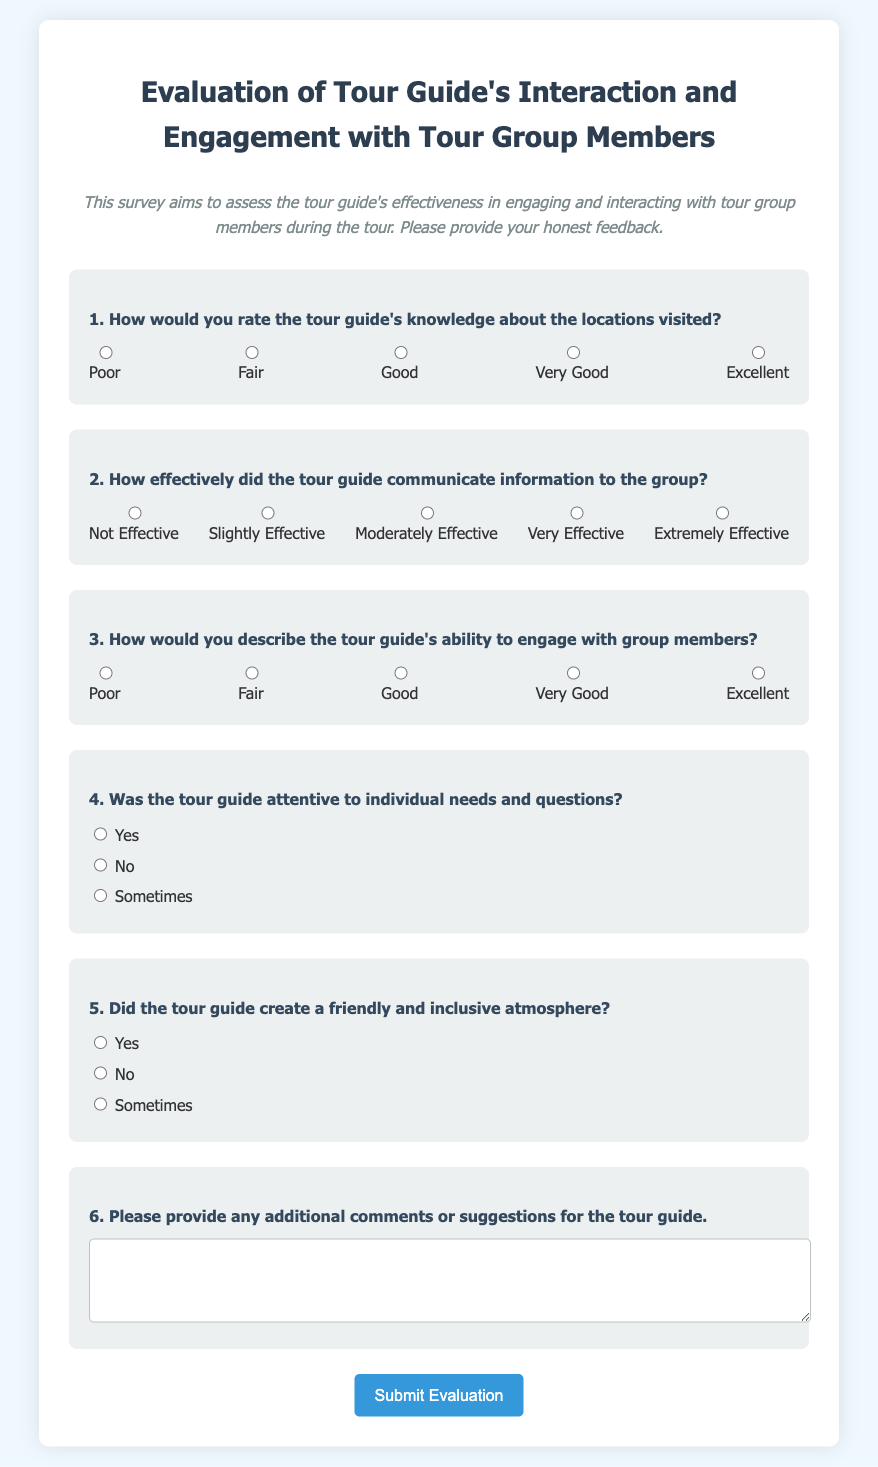What is the title of the survey? The title of the survey is stated at the top of the document, which assesses the effectiveness of the tour guide's engaging methods.
Answer: Evaluation of Tour Guide's Interaction and Engagement with Tour Group Members How many rating options are provided for the first question? The first question contains five rating options, which range from Poor to Excellent.
Answer: Five What type of question is question four? The fourth question is a multiple-choice question that requires a yes, no, or sometimes response regarding the tour guide's attentiveness.
Answer: Multiple-choice What is the rating for the second question? The second question asks respondents to rate the effectiveness of communication on a scale of 1 to 5, where 1 is Not Effective and 5 is Extremely Effective.
Answer: 1 to 5 How does the survey ask for additional comments? The survey includes a section with a textarea for participants to provide any extra comments or suggestions for the tour guide.
Answer: Textarea 